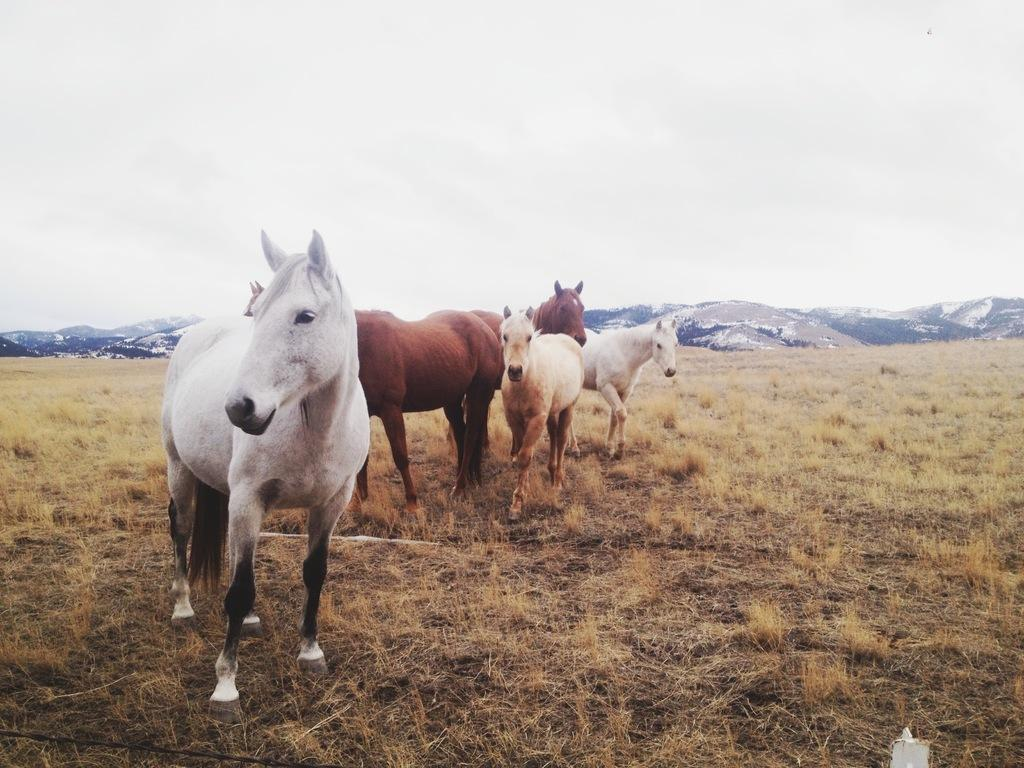What animals are present in the image? There are horses in the image. What type of vegetation can be seen in the background of the image? There is grass in the background of the image. What natural features are visible in the background of the image? There are mountains in the background of the image. What part of the natural environment is visible in the image? The sky is visible in the background of the image. How many frogs can be seen in the room in the image? There is no room or frogs present in the image; it features horses in an outdoor setting. 